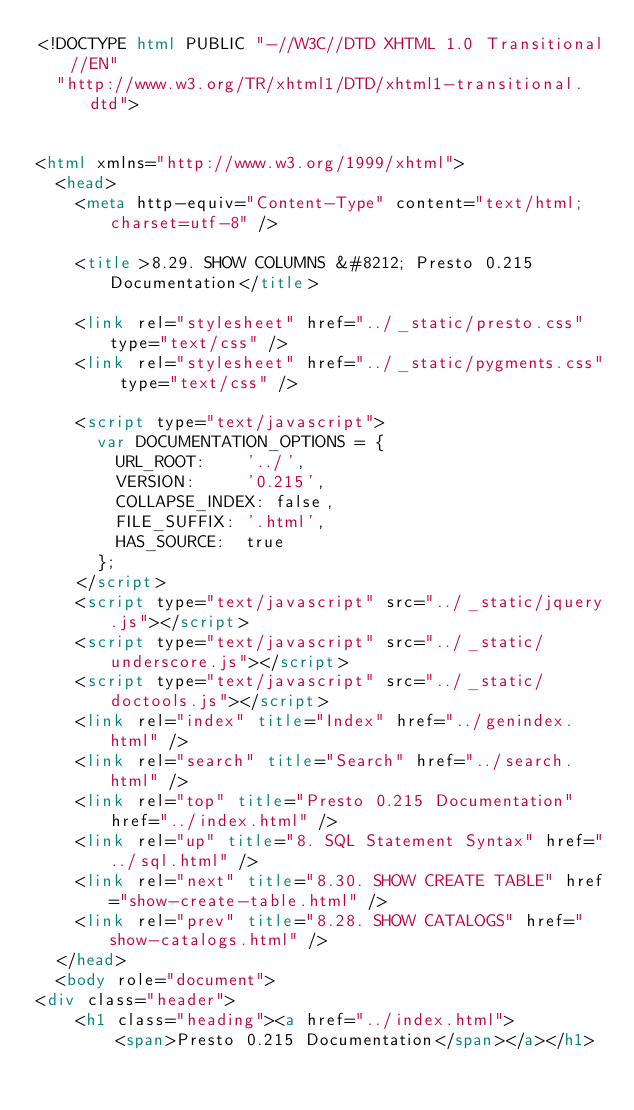Convert code to text. <code><loc_0><loc_0><loc_500><loc_500><_HTML_><!DOCTYPE html PUBLIC "-//W3C//DTD XHTML 1.0 Transitional//EN"
  "http://www.w3.org/TR/xhtml1/DTD/xhtml1-transitional.dtd">


<html xmlns="http://www.w3.org/1999/xhtml">
  <head>
    <meta http-equiv="Content-Type" content="text/html; charset=utf-8" />
    
    <title>8.29. SHOW COLUMNS &#8212; Presto 0.215 Documentation</title>
    
    <link rel="stylesheet" href="../_static/presto.css" type="text/css" />
    <link rel="stylesheet" href="../_static/pygments.css" type="text/css" />
    
    <script type="text/javascript">
      var DOCUMENTATION_OPTIONS = {
        URL_ROOT:    '../',
        VERSION:     '0.215',
        COLLAPSE_INDEX: false,
        FILE_SUFFIX: '.html',
        HAS_SOURCE:  true
      };
    </script>
    <script type="text/javascript" src="../_static/jquery.js"></script>
    <script type="text/javascript" src="../_static/underscore.js"></script>
    <script type="text/javascript" src="../_static/doctools.js"></script>
    <link rel="index" title="Index" href="../genindex.html" />
    <link rel="search" title="Search" href="../search.html" />
    <link rel="top" title="Presto 0.215 Documentation" href="../index.html" />
    <link rel="up" title="8. SQL Statement Syntax" href="../sql.html" />
    <link rel="next" title="8.30. SHOW CREATE TABLE" href="show-create-table.html" />
    <link rel="prev" title="8.28. SHOW CATALOGS" href="show-catalogs.html" /> 
  </head>
  <body role="document">
<div class="header">
    <h1 class="heading"><a href="../index.html">
        <span>Presto 0.215 Documentation</span></a></h1></code> 